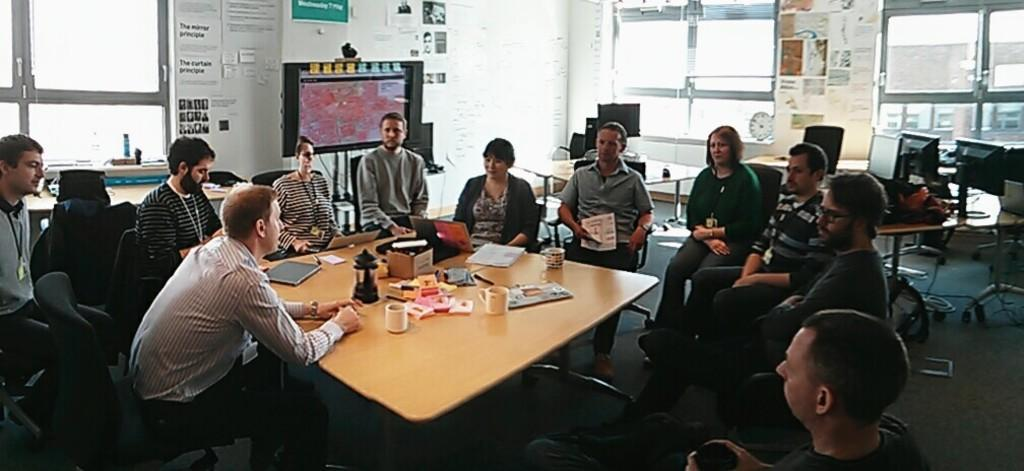How many people are in the image? There is a group of people in the image. What are the people doing in the image? The people are sitting at a table. What objects can be seen on the table? There is a book, a laptop, and a coffee mug on the table. What is visible in the background of the image? There are windows in the background of the image. What type of pen is being used for observation in the image? There is no pen present in the image, and no observation is being conducted. 